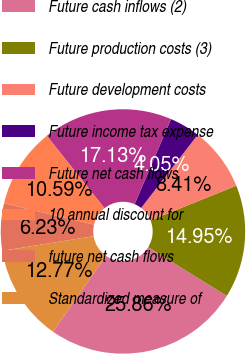Convert chart. <chart><loc_0><loc_0><loc_500><loc_500><pie_chart><fcel>Future cash inflows (2)<fcel>Future production costs (3)<fcel>Future development costs<fcel>Future income tax expense<fcel>Future net cash flows<fcel>10 annual discount for<fcel>future net cash flows<fcel>Standardized measure of<nl><fcel>25.85%<fcel>14.95%<fcel>8.41%<fcel>4.05%<fcel>17.13%<fcel>10.59%<fcel>6.23%<fcel>12.77%<nl></chart> 